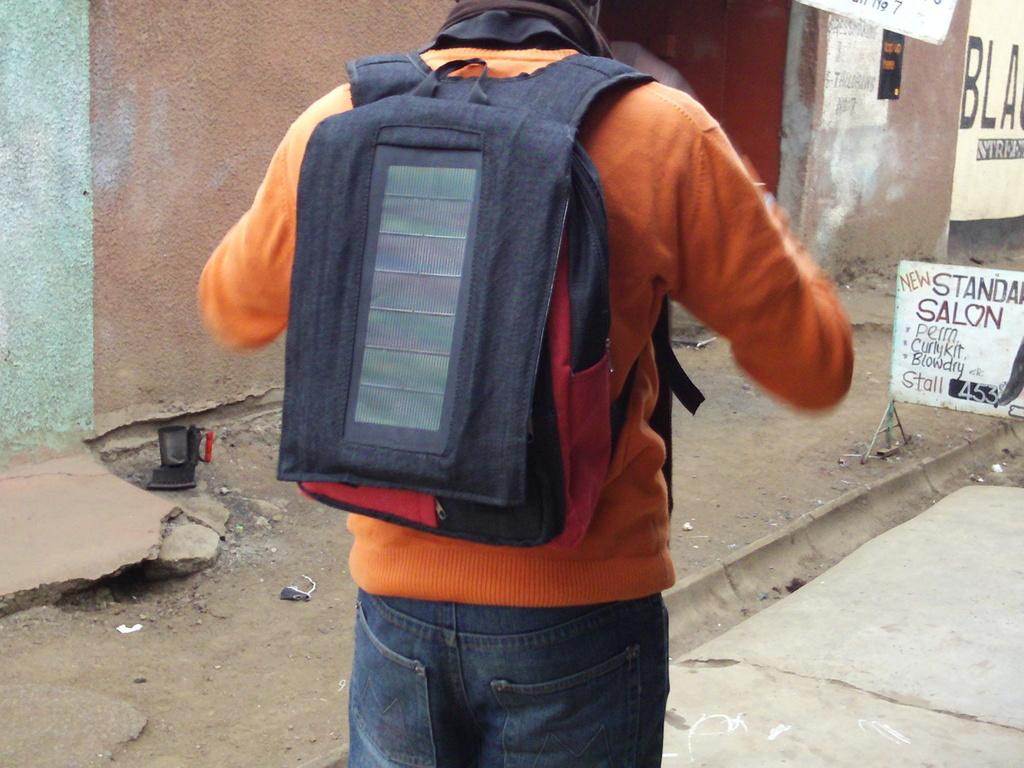<image>
Write a terse but informative summary of the picture. A simple handwritten sign advertises a new salon as a man walks past. 